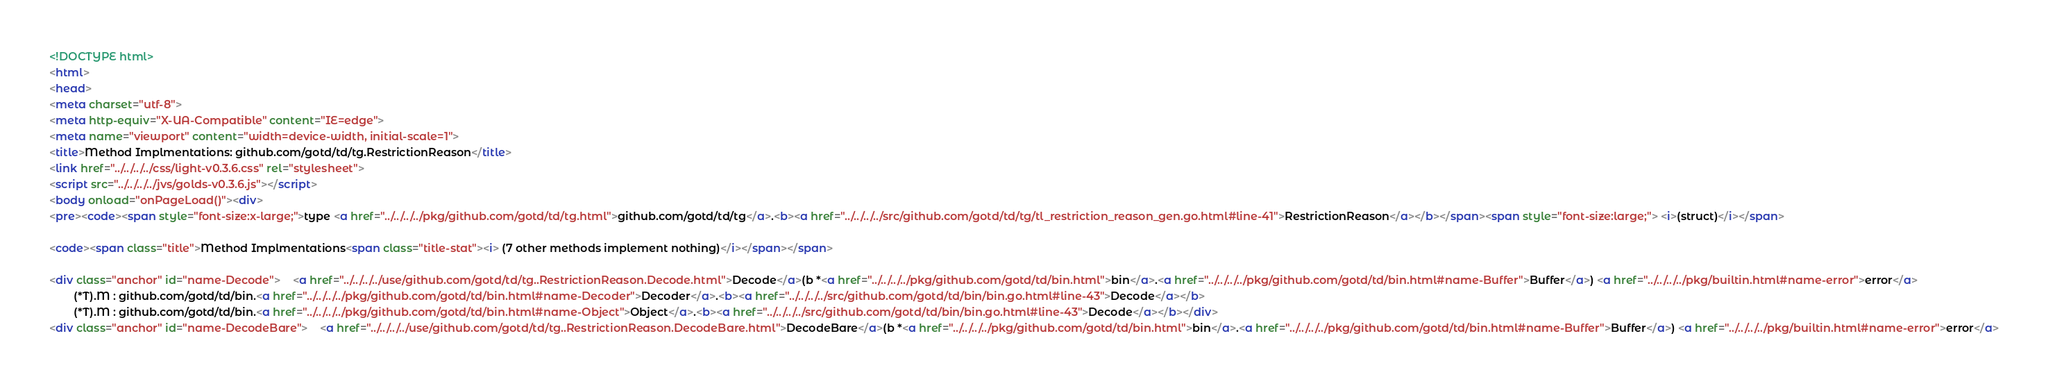<code> <loc_0><loc_0><loc_500><loc_500><_HTML_><!DOCTYPE html>
<html>
<head>
<meta charset="utf-8">
<meta http-equiv="X-UA-Compatible" content="IE=edge">
<meta name="viewport" content="width=device-width, initial-scale=1">
<title>Method Implmentations: github.com/gotd/td/tg.RestrictionReason</title>
<link href="../../../../css/light-v0.3.6.css" rel="stylesheet">
<script src="../../../../jvs/golds-v0.3.6.js"></script>
<body onload="onPageLoad()"><div>
<pre><code><span style="font-size:x-large;">type <a href="../../../../pkg/github.com/gotd/td/tg.html">github.com/gotd/td/tg</a>.<b><a href="../../../../src/github.com/gotd/td/tg/tl_restriction_reason_gen.go.html#line-41">RestrictionReason</a></b></span><span style="font-size:large;"> <i>(struct)</i></span>

<code><span class="title">Method Implmentations<span class="title-stat"><i> (7 other methods implement nothing)</i></span></span>

<div class="anchor" id="name-Decode">	<a href="../../../../use/github.com/gotd/td/tg..RestrictionReason.Decode.html">Decode</a>(b *<a href="../../../../pkg/github.com/gotd/td/bin.html">bin</a>.<a href="../../../../pkg/github.com/gotd/td/bin.html#name-Buffer">Buffer</a>) <a href="../../../../pkg/builtin.html#name-error">error</a>
		(*T).M : github.com/gotd/td/bin.<a href="../../../../pkg/github.com/gotd/td/bin.html#name-Decoder">Decoder</a>.<b><a href="../../../../src/github.com/gotd/td/bin/bin.go.html#line-43">Decode</a></b>
		(*T).M : github.com/gotd/td/bin.<a href="../../../../pkg/github.com/gotd/td/bin.html#name-Object">Object</a>.<b><a href="../../../../src/github.com/gotd/td/bin/bin.go.html#line-43">Decode</a></b></div>
<div class="anchor" id="name-DecodeBare">	<a href="../../../../use/github.com/gotd/td/tg..RestrictionReason.DecodeBare.html">DecodeBare</a>(b *<a href="../../../../pkg/github.com/gotd/td/bin.html">bin</a>.<a href="../../../../pkg/github.com/gotd/td/bin.html#name-Buffer">Buffer</a>) <a href="../../../../pkg/builtin.html#name-error">error</a></code> 